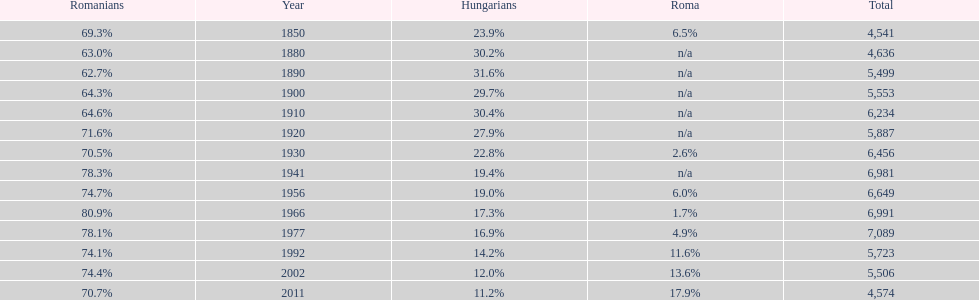Which year had the top percentage in romanian population? 1966. 